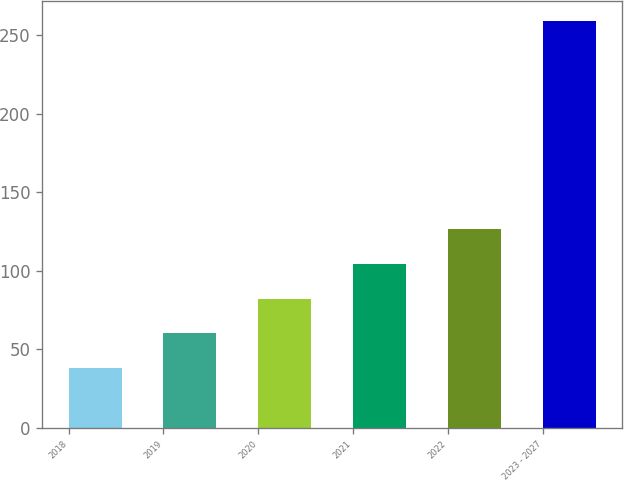Convert chart to OTSL. <chart><loc_0><loc_0><loc_500><loc_500><bar_chart><fcel>2018<fcel>2019<fcel>2020<fcel>2021<fcel>2022<fcel>2023 - 2027<nl><fcel>38<fcel>60.1<fcel>82.2<fcel>104.3<fcel>126.4<fcel>259<nl></chart> 